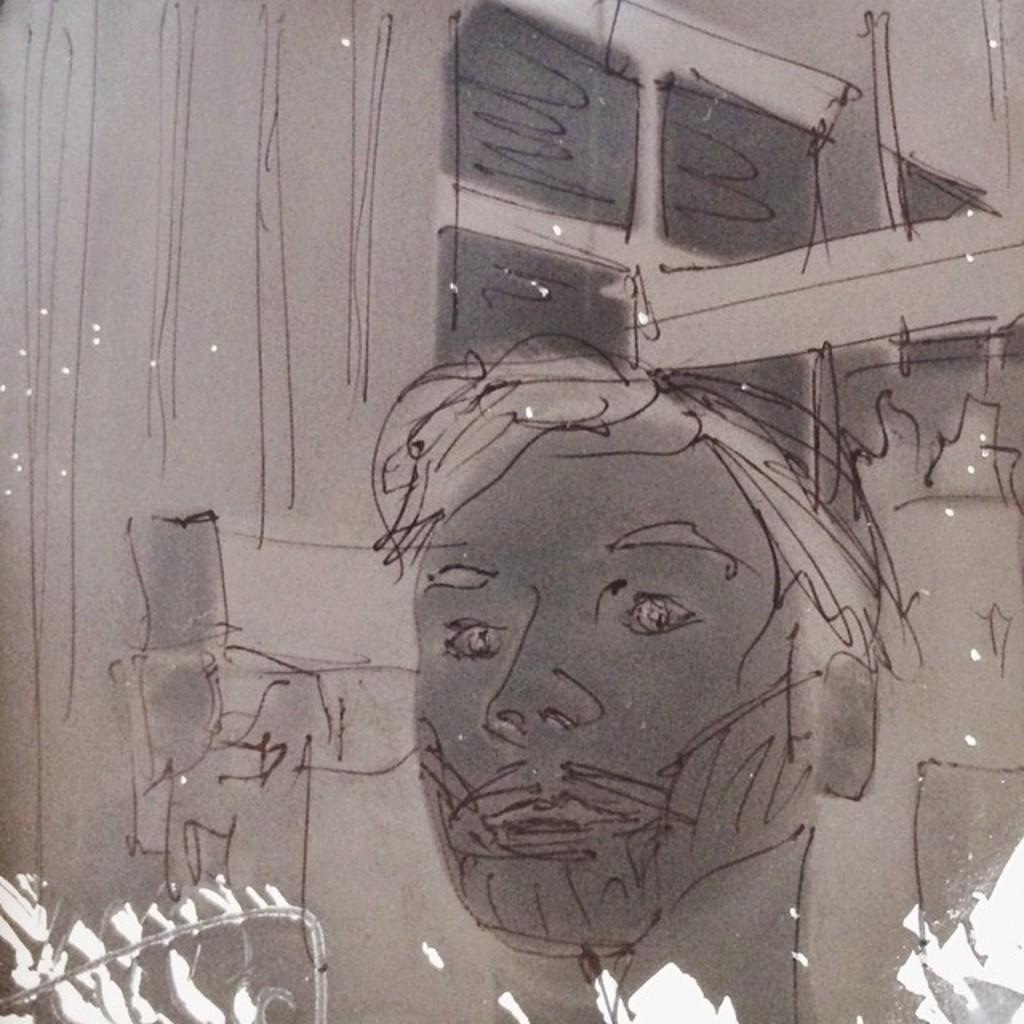In one or two sentences, can you explain what this image depicts? In this image there is a drawing, at the bottom there is some light. 